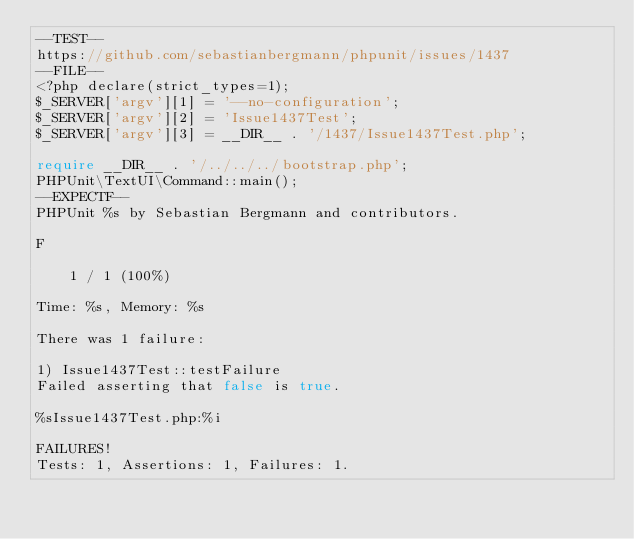<code> <loc_0><loc_0><loc_500><loc_500><_PHP_>--TEST--
https://github.com/sebastianbergmann/phpunit/issues/1437
--FILE--
<?php declare(strict_types=1);
$_SERVER['argv'][1] = '--no-configuration';
$_SERVER['argv'][2] = 'Issue1437Test';
$_SERVER['argv'][3] = __DIR__ . '/1437/Issue1437Test.php';

require __DIR__ . '/../../../bootstrap.php';
PHPUnit\TextUI\Command::main();
--EXPECTF--
PHPUnit %s by Sebastian Bergmann and contributors.

F                                                                   1 / 1 (100%)

Time: %s, Memory: %s

There was 1 failure:

1) Issue1437Test::testFailure
Failed asserting that false is true.

%sIssue1437Test.php:%i

FAILURES!
Tests: 1, Assertions: 1, Failures: 1.
</code> 